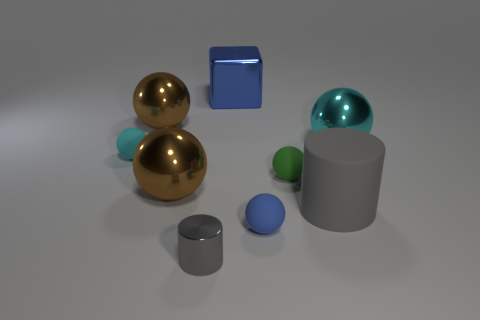What number of other objects are there of the same color as the shiny cube?
Your response must be concise. 1. The gray metallic object has what size?
Ensure brevity in your answer.  Small. Are there more brown shiny spheres that are left of the blue metallic thing than large brown things behind the green sphere?
Provide a succinct answer. Yes. How many green objects are behind the large ball on the right side of the small metal cylinder?
Make the answer very short. 0. There is a blue thing that is right of the blue metal object; does it have the same shape as the gray rubber thing?
Keep it short and to the point. No. What is the material of the tiny cyan thing that is the same shape as the small green thing?
Give a very brief answer. Rubber. How many gray matte objects are the same size as the blue metallic block?
Your answer should be compact. 1. There is a sphere that is in front of the tiny green thing and left of the tiny gray shiny object; what color is it?
Your answer should be compact. Brown. Are there fewer big purple rubber cylinders than tiny cyan rubber spheres?
Provide a short and direct response. Yes. There is a big shiny block; does it have the same color as the small ball that is to the left of the small gray shiny cylinder?
Offer a very short reply. No. 